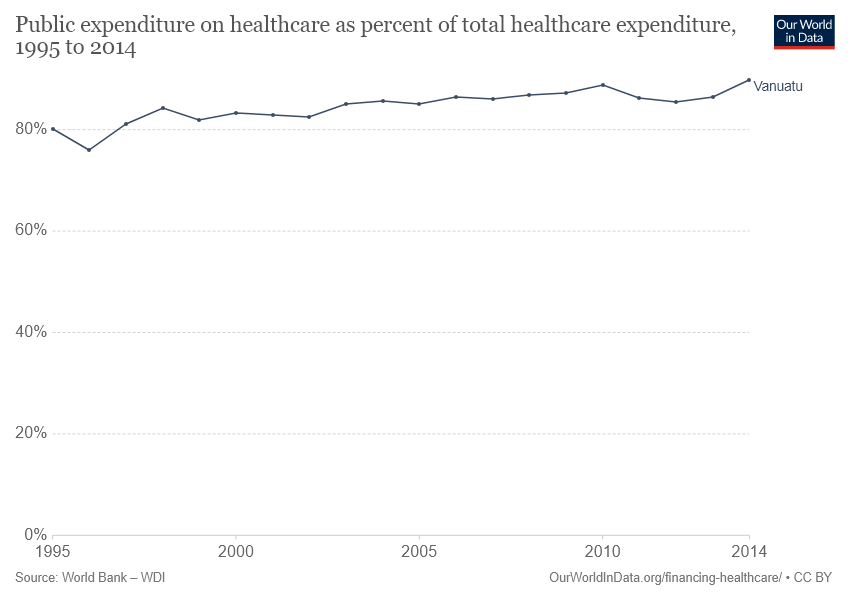List a handful of essential elements in this visual. The total number of dot points on the line is 20. 